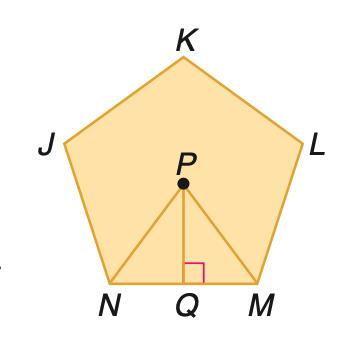Question: Find the area of a regular pentagon with a perimeter of 40 centimeters.
Choices:
A. 88
B. 110
C. 132
D. 160
Answer with the letter. Answer: B 